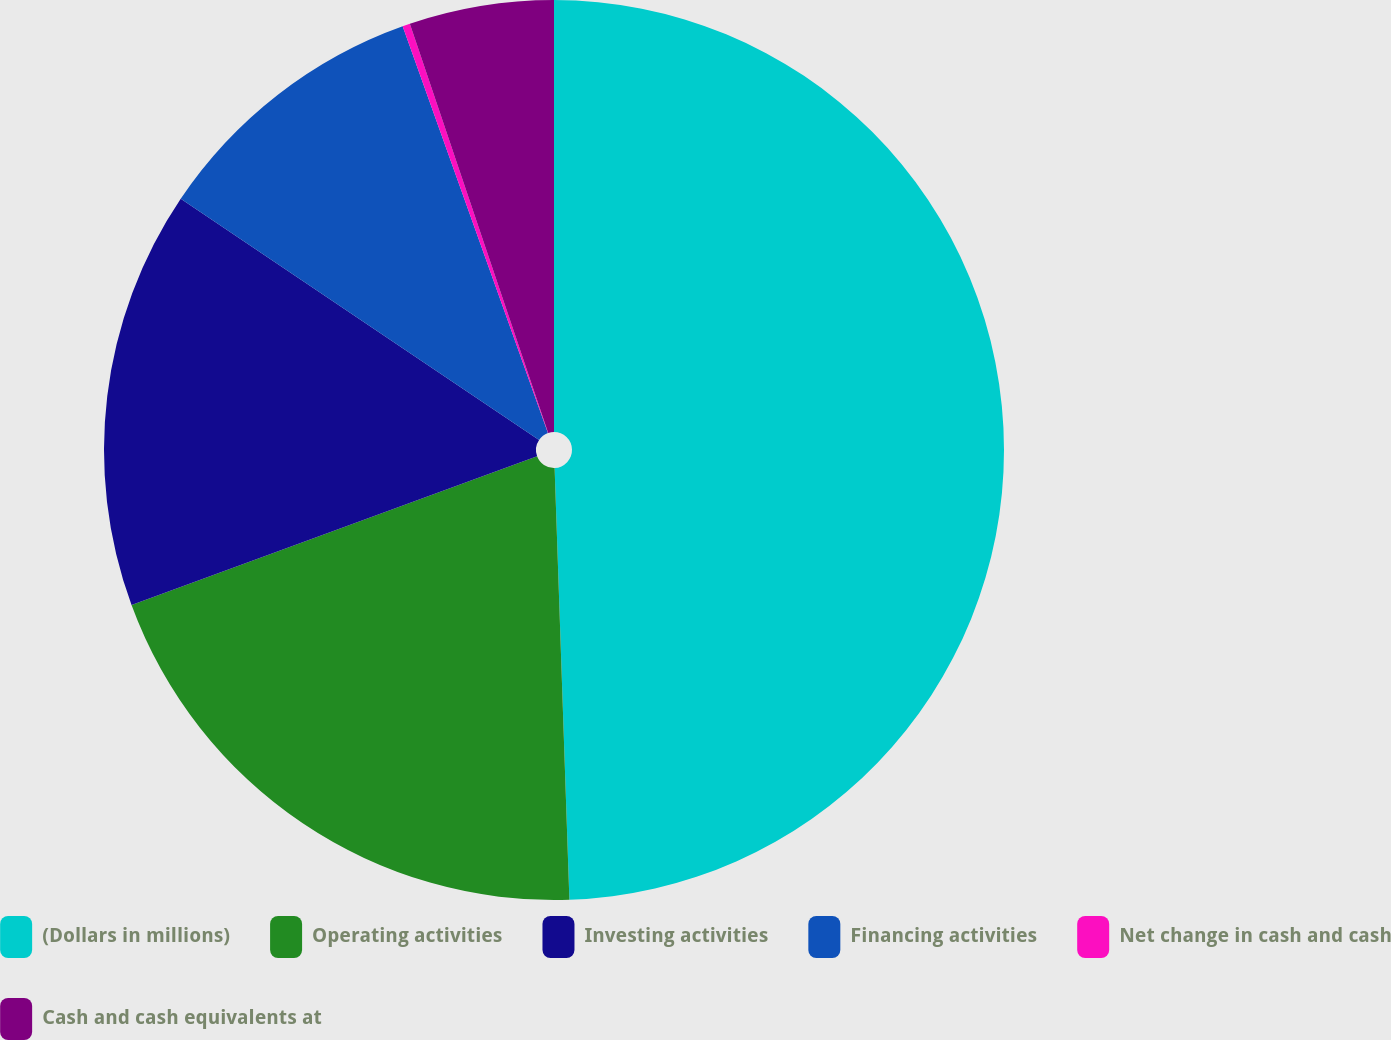<chart> <loc_0><loc_0><loc_500><loc_500><pie_chart><fcel>(Dollars in millions)<fcel>Operating activities<fcel>Investing activities<fcel>Financing activities<fcel>Net change in cash and cash<fcel>Cash and cash equivalents at<nl><fcel>49.46%<fcel>19.95%<fcel>15.03%<fcel>10.11%<fcel>0.27%<fcel>5.19%<nl></chart> 